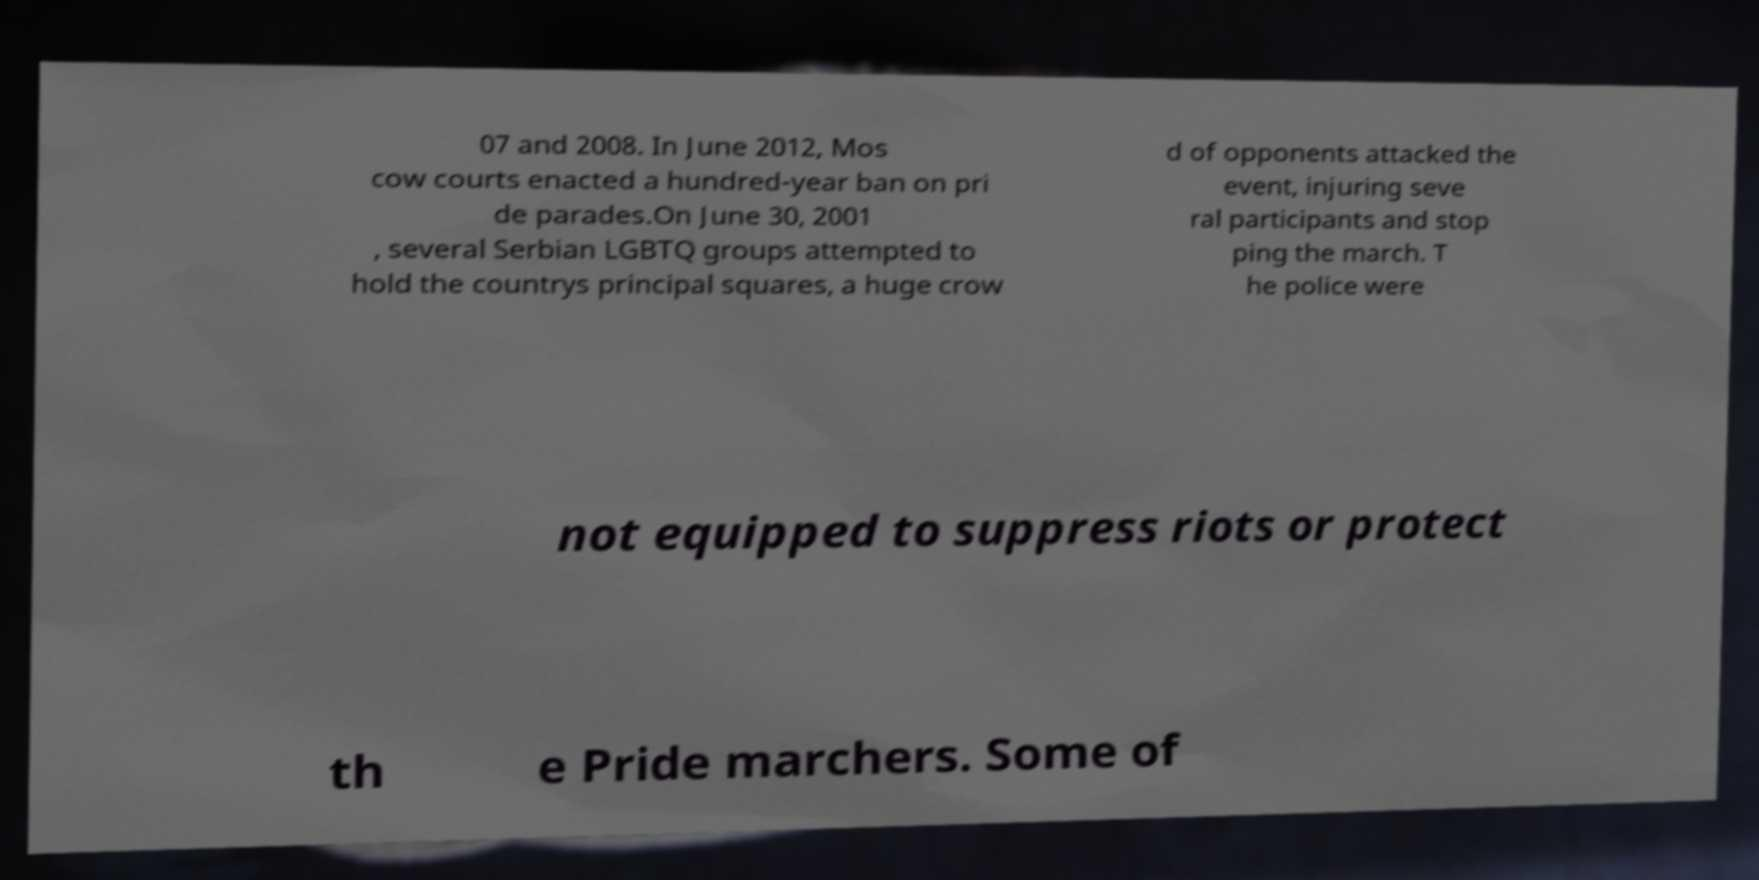Please identify and transcribe the text found in this image. 07 and 2008. In June 2012, Mos cow courts enacted a hundred-year ban on pri de parades.On June 30, 2001 , several Serbian LGBTQ groups attempted to hold the countrys principal squares, a huge crow d of opponents attacked the event, injuring seve ral participants and stop ping the march. T he police were not equipped to suppress riots or protect th e Pride marchers. Some of 